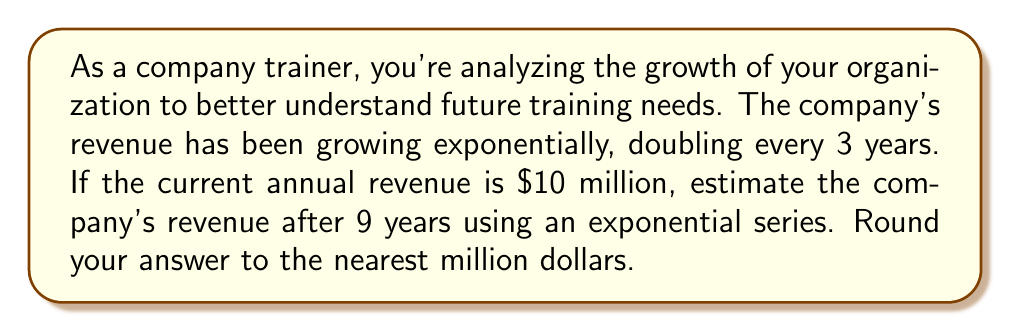Can you solve this math problem? Let's approach this step-by-step:

1) First, we need to identify the components of our exponential growth formula:
   $A = P(1+r)^t$
   Where:
   $A$ = Final amount
   $P$ = Initial principal balance
   $r$ = Growth rate (in decimal form)
   $t$ = Time period

2) We know that the revenue doubles every 3 years. We can use this to find the growth rate:
   $2 = (1+r)^3$
   $\sqrt[3]{2} = 1+r$
   $r = \sqrt[3]{2} - 1 \approx 0.2599$ or about 26% per year

3) Now we have:
   $P = \$10$ million (initial revenue)
   $r = 0.2599$
   $t = 9$ years

4) Plugging these into our formula:
   $A = 10(1+0.2599)^9$

5) We can expand this using the binomial series:
   $A = 10(1 + 9(0.2599) + \frac{9 \cdot 8}{2!}(0.2599)^2 + \frac{9 \cdot 8 \cdot 7}{3!}(0.2599)^3 + ...)$

6) Calculating the first few terms:
   $A = 10(1 + 2.3391 + 2.4505 + 1.7123 + ...)$
   $A = 10(7.5019 + ...)$

7) This is already more than 7.5 times the initial amount, so we can estimate the final amount to be around $75 million.

8) Using a calculator for precise calculation:
   $A = 10(1.2599)^9 \approx 79.99$ million

9) Rounding to the nearest million:
   $A \approx 80$ million
Answer: $80 million 